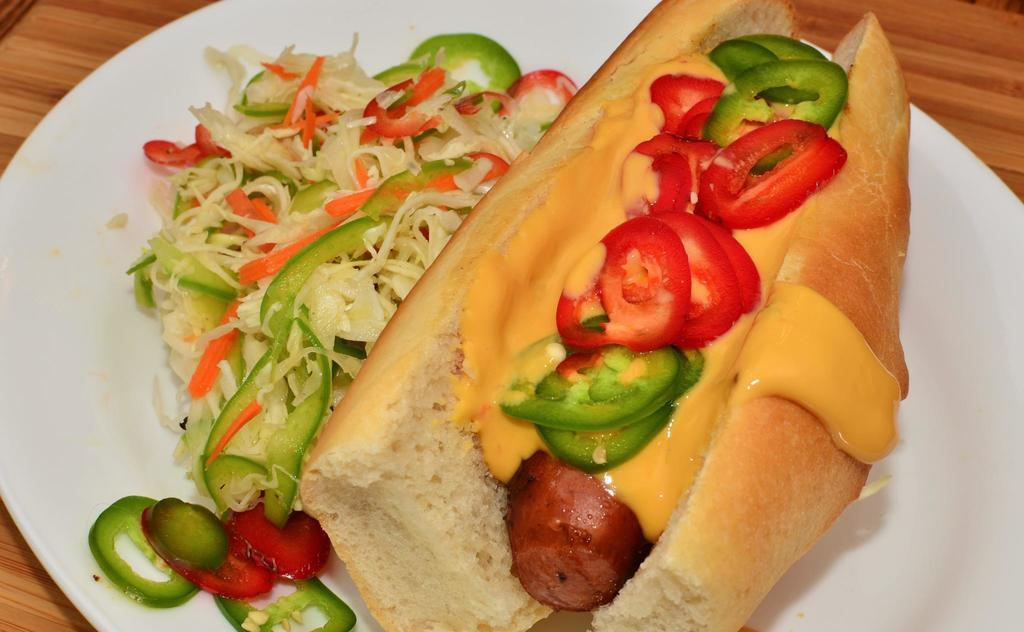What is on the plate that is visible in the image? There are food items in a plate. Where is the plate located in the image? The plate is on a table. What type of statement can be seen written on the plate? There is no statement written on the plate in the image. Can you see a cat sitting next to the table in the image? There is no cat present in the image. 